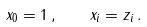Convert formula to latex. <formula><loc_0><loc_0><loc_500><loc_500>x _ { 0 } = 1 \, , \quad x _ { i } = z _ { i } \, .</formula> 